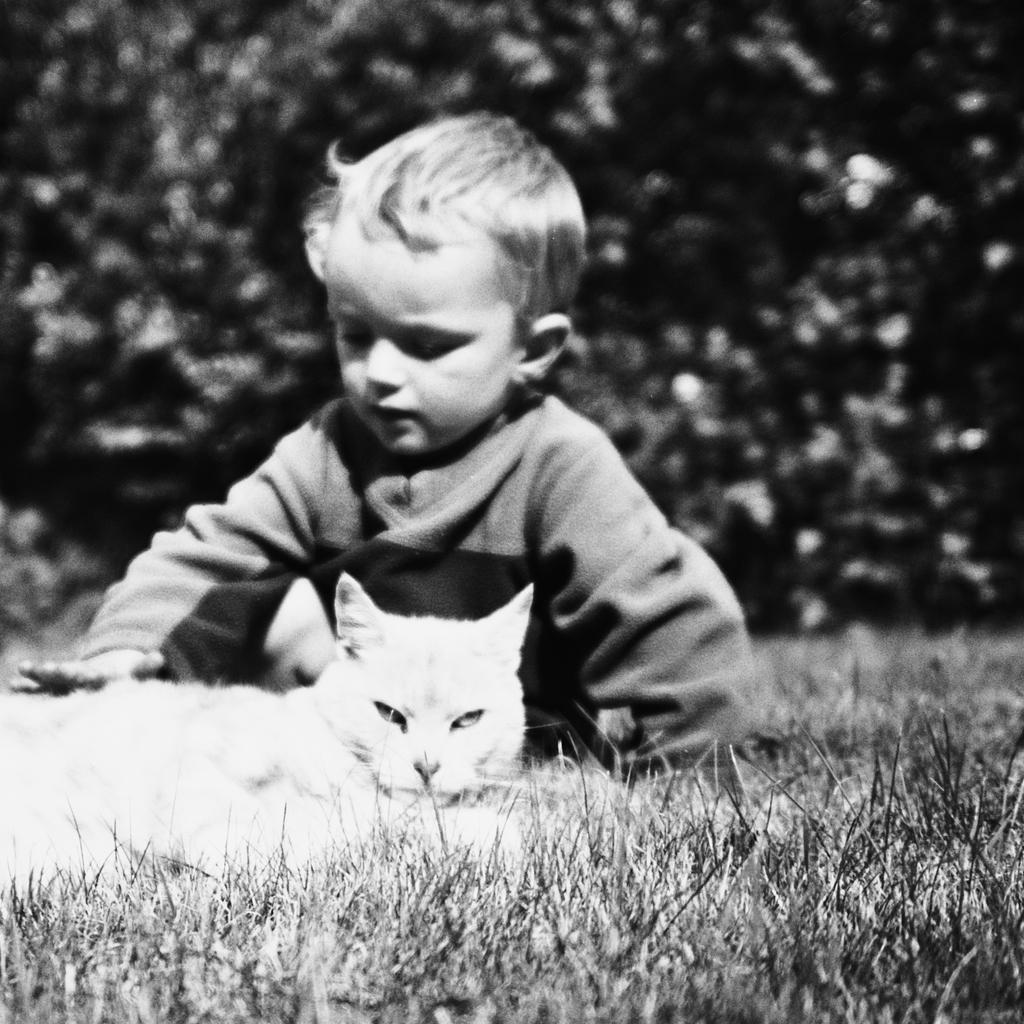What is the main subject of the image? The main subject of the image is a little baby. Are there any other living creatures present in the image? Yes, there is a cat in the image. Where are the baby and cat located? The baby and cat are on the grass. What type of natural environment is visible in the image? There are trees visible in the image. What type of brass instrument is the baby playing in the image? There is no brass instrument present in the image. What type of railway system can be seen in the image? There is no railway system present in the image. What type of mint plant is growing near the baby and cat? There is no mint plant present in the image. 